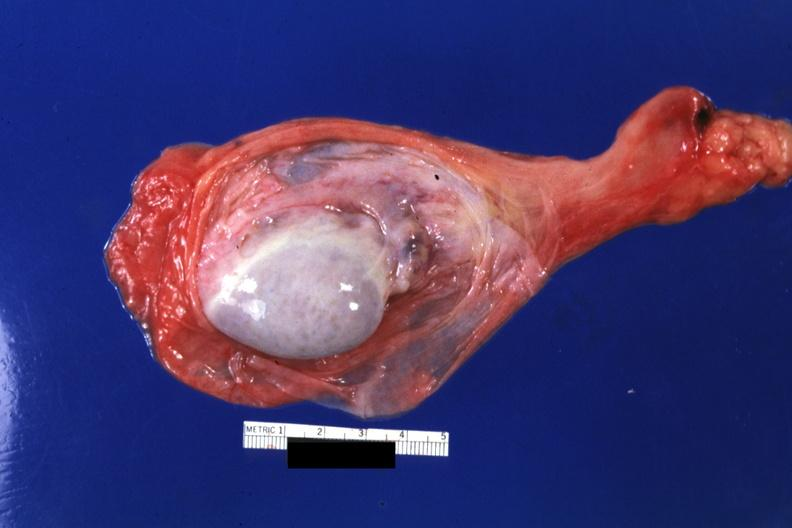s sac opened?
Answer the question using a single word or phrase. Yes 